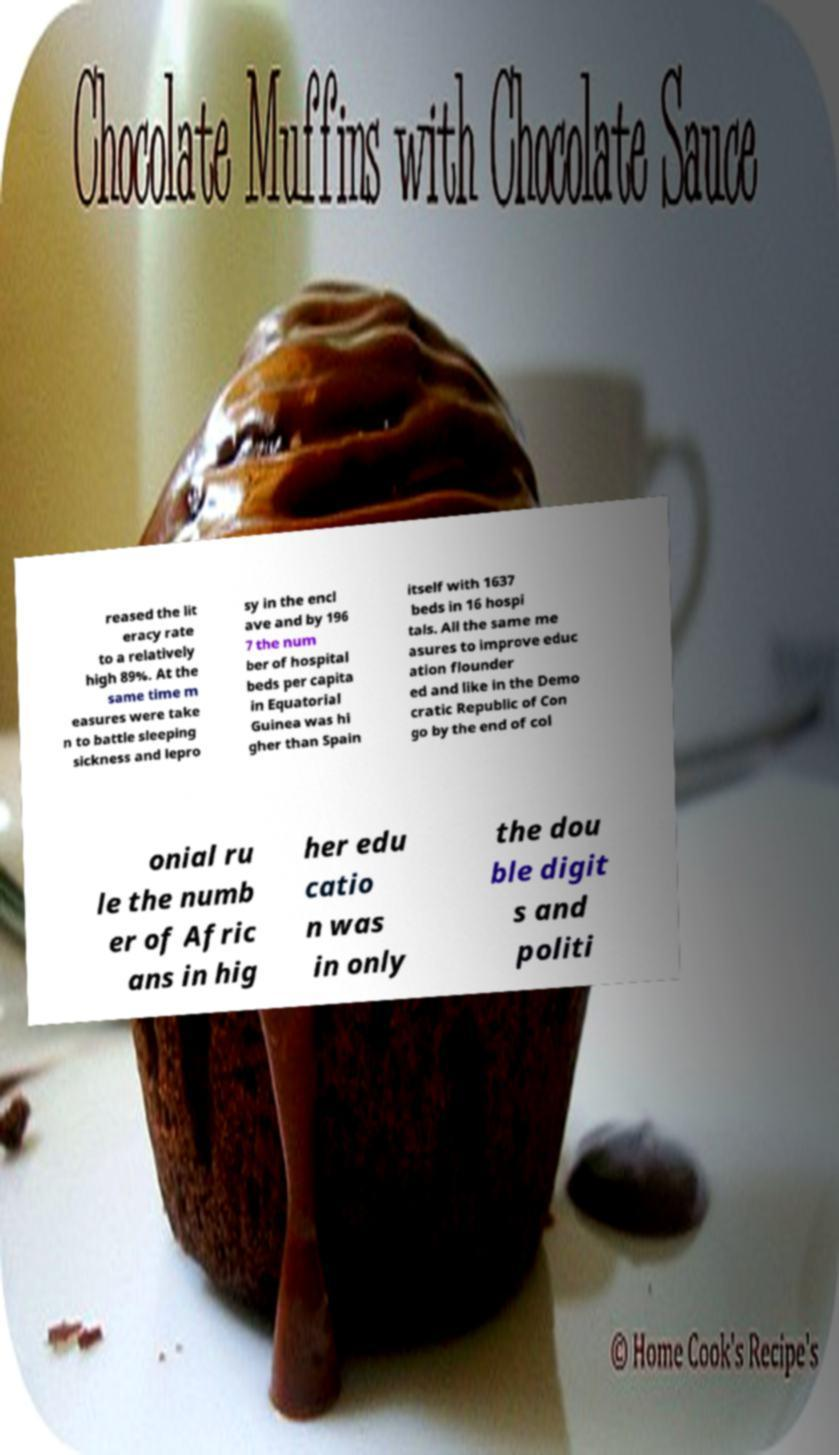Could you assist in decoding the text presented in this image and type it out clearly? reased the lit eracy rate to a relatively high 89%. At the same time m easures were take n to battle sleeping sickness and lepro sy in the encl ave and by 196 7 the num ber of hospital beds per capita in Equatorial Guinea was hi gher than Spain itself with 1637 beds in 16 hospi tals. All the same me asures to improve educ ation flounder ed and like in the Demo cratic Republic of Con go by the end of col onial ru le the numb er of Afric ans in hig her edu catio n was in only the dou ble digit s and politi 